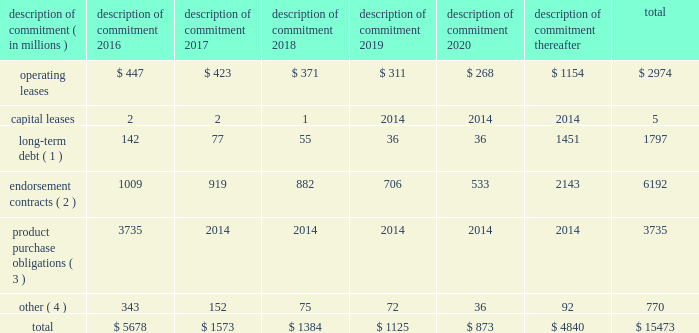Part ii were issued in an initial aggregate principal amount of $ 500 million at a 2.25% ( 2.25 % ) fixed , annual interest rate and will mature on may 1 , 2023 .
The 2043 senior notes were issued in an initial aggregate principal amount of $ 500 million at a 3.625% ( 3.625 % ) fixed , annual interest rate and will mature on may 1 , 2043 .
Interest on the senior notes is payable semi-annually on may 1 and november 1 of each year .
The issuance resulted in gross proceeds before expenses of $ 998 million .
On november 1 , 2011 , we entered into a committed credit facility agreement with a syndicate of banks which provides for up to $ 1 billion of borrowings with the option to increase borrowings to $ 1.5 billion with lender approval .
The facility matures november 1 , 2017 .
As of and for the periods ended may 31 , 2015 and 2014 , we had no amounts outstanding under our committed credit facility .
We currently have long-term debt ratings of aa- and a1 from standard and poor 2019s corporation and moody 2019s investor services , respectively .
If our long- term debt ratings were to decline , the facility fee and interest rate under our committed credit facility would increase .
Conversely , if our long-term debt rating were to improve , the facility fee and interest rate would decrease .
Changes in our long-term debt rating would not trigger acceleration of maturity of any then-outstanding borrowings or any future borrowings under the committed credit facility .
Under this committed revolving credit facility , we have agreed to various covenants .
These covenants include limits on our disposal of fixed assets , the amount of debt secured by liens we may incur , as well as a minimum capitalization ratio .
In the event we were to have any borrowings outstanding under this facility and failed to meet any covenant , and were unable to obtain a waiver from a majority of the banks in the syndicate , any borrowings would become immediately due and payable .
As of may 31 , 2015 , we were in full compliance with each of these covenants and believe it is unlikely we will fail to meet any of these covenants in the foreseeable future .
Liquidity is also provided by our $ 1 billion commercial paper program .
During the year ended may 31 , 2015 , we did not issue commercial paper , and as of may 31 , 2015 , there were no outstanding borrowings under this program .
We may issue commercial paper or other debt securities during fiscal 2016 depending on general corporate needs .
We currently have short-term debt ratings of a1+ and p1 from standard and poor 2019s corporation and moody 2019s investor services , respectively .
As of may 31 , 2015 , we had cash , cash equivalents and short-term investments totaling $ 5.9 billion , of which $ 4.2 billion was held by our foreign subsidiaries .
Included in cash and equivalents as of may 31 , 2015 was $ 968 million of cash collateral received from counterparties as a result of hedging activity .
Cash equivalents and short-term investments consist primarily of deposits held at major banks , money market funds , commercial paper , corporate notes , u.s .
Treasury obligations , u.s .
Government sponsored enterprise obligations and other investment grade fixed income securities .
Our fixed income investments are exposed to both credit and interest rate risk .
All of our investments are investment grade to minimize our credit risk .
While individual securities have varying durations , as of may 31 , 2015 the weighted average remaining duration of our short-term investments and cash equivalents portfolio was 79 days .
To date we have not experienced difficulty accessing the credit markets or incurred higher interest costs .
Future volatility in the capital markets , however , may increase costs associated with issuing commercial paper or other debt instruments or affect our ability to access those markets .
We believe that existing cash , cash equivalents , short-term investments and cash generated by operations , together with access to external sources of funds as described above , will be sufficient to meet our domestic and foreign capital needs in the foreseeable future .
We utilize a variety of tax planning and financing strategies to manage our worldwide cash and deploy funds to locations where they are needed .
We routinely repatriate a portion of our foreign earnings for which u.s .
Taxes have previously been provided .
We also indefinitely reinvest a significant portion of our foreign earnings , and our current plans do not demonstrate a need to repatriate these earnings .
Should we require additional capital in the united states , we may elect to repatriate indefinitely reinvested foreign funds or raise capital in the united states through debt .
If we were to repatriate indefinitely reinvested foreign funds , we would be required to accrue and pay additional u.s .
Taxes less applicable foreign tax credits .
If we elect to raise capital in the united states through debt , we would incur additional interest expense .
Off-balance sheet arrangements in connection with various contracts and agreements , we routinely provide indemnification relating to the enforceability of intellectual property rights , coverage for legal issues that arise and other items where we are acting as the guarantor .
Currently , we have several such agreements in place .
However , based on our historical experience and the estimated probability of future loss , we have determined that the fair value of such indemnification is not material to our financial position or results of operations .
Contractual obligations our significant long-term contractual obligations as of may 31 , 2015 and significant endorsement contracts , including related marketing commitments , entered into through the date of this report are as follows: .
( 1 ) the cash payments due for long-term debt include estimated interest payments .
Estimates of interest payments are based on outstanding principal amounts , applicable fixed interest rates or currently effective interest rates as of may 31 , 2015 ( if variable ) , timing of scheduled payments and the term of the debt obligations .
( 2 ) the amounts listed for endorsement contracts represent approximate amounts of base compensation and minimum guaranteed royalty fees we are obligated to pay athlete , sport team and league endorsers of our products .
Actual payments under some contracts may be higher than the amounts listed as these contracts provide for bonuses to be paid to the endorsers based upon athletic achievements and/or royalties on product sales in future periods .
Actual payments under some contracts may also be lower as these contracts include provisions for reduced payments if athletic performance declines in future periods .
In addition to the cash payments , we are obligated to furnish our endorsers with nike product for their use .
It is not possible to determine how much we will spend on this product on an annual basis as the contracts generally do not stipulate a specific amount of cash to be spent on the product .
The amount of product provided to the endorsers will depend on many factors , including general playing conditions , the number of sporting events in which they participate and our own decisions regarding product and marketing initiatives .
In addition , the costs to design , develop , source and purchase the products furnished to the endorsers are incurred over a period of time and are not necessarily tracked separately from similar costs incurred for products sold to customers. .
What percent of the total for all years was due to contributions form the year 2020? 
Computations: (873 / 15473)
Answer: 0.05642. 